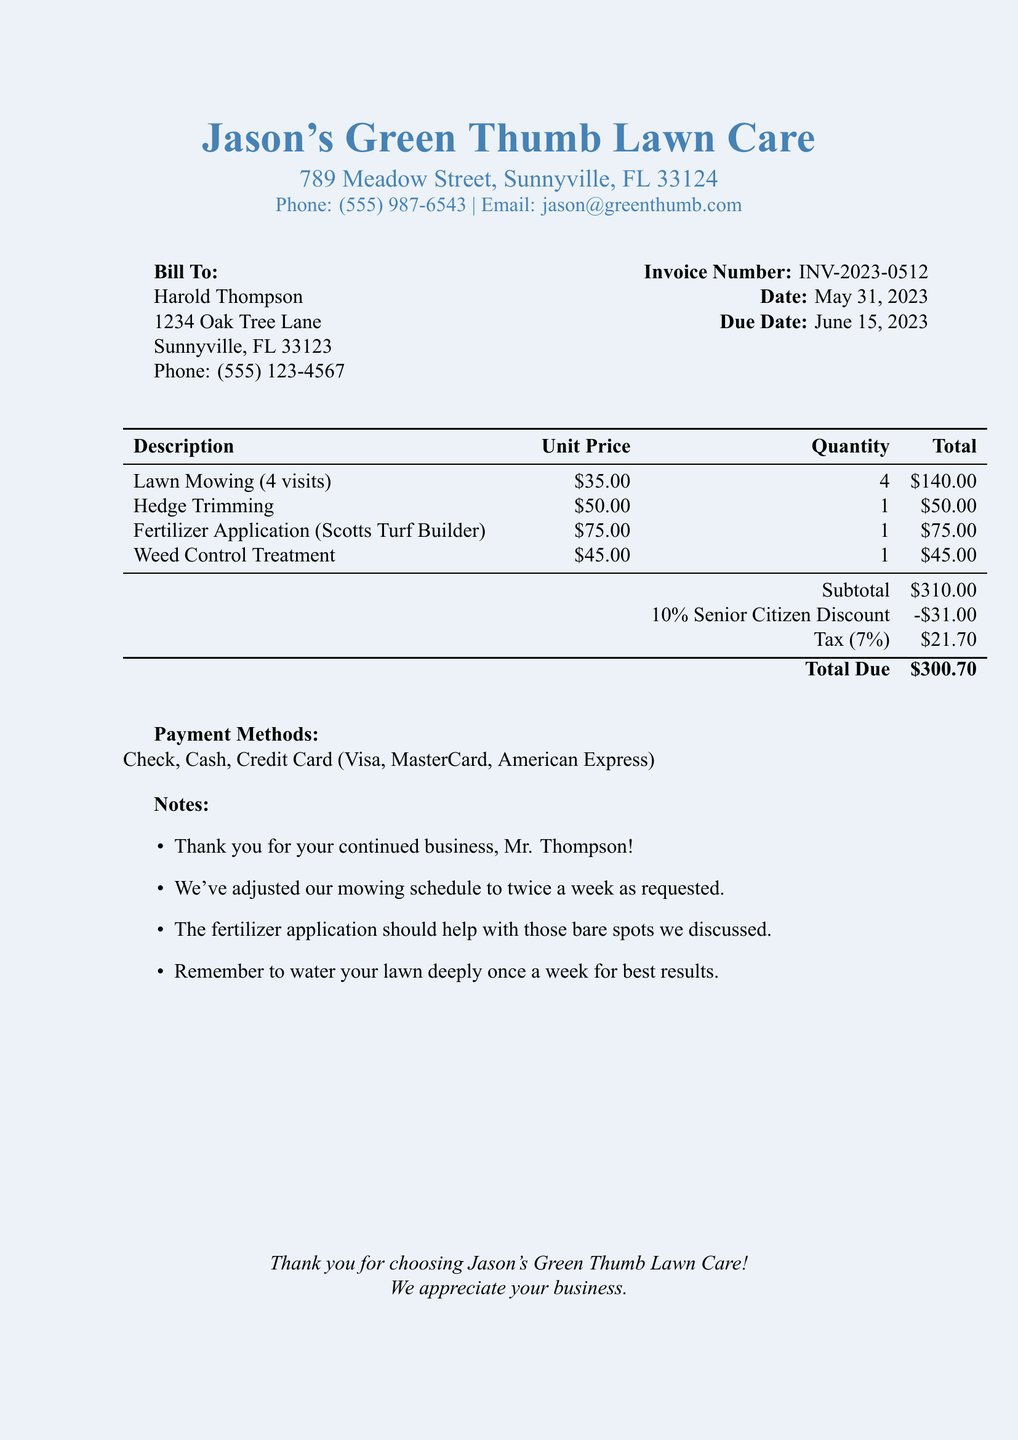What is the invoice number? The invoice number is specified in the document under invoice details.
Answer: INV-2023-0512 What is the total amount due? The total due is calculated at the end of the invoice after applying discounts and taxes.
Answer: $300.70 What discount is applied? The senior discount mentioned is listed in the totals section.
Answer: 10% Senior Citizen Discount What is the unit price for hedge trimming? The unit price for hedge trimming is found in the services table.
Answer: $50.00 How many visits were included for lawn mowing? The number of visits for lawn mowing is stated in the description of the service.
Answer: 4 visits What is the due date for the invoice? The due date can be found in the invoice details section.
Answer: June 15, 2023 What payment methods are accepted? The payment methods are listed in a separate section of the invoice.
Answer: Check, Cash, Credit Card (Visa, MasterCard, American Express) What is the subtotal before tax? The subtotal amount before tax and discounts is provided in the totals section.
Answer: $310.00 What services were provided? The services provided are listed in the services section of the invoice.
Answer: Lawn Mowing, Hedge Trimming, Fertilizer Application, Weed Control Treatment 